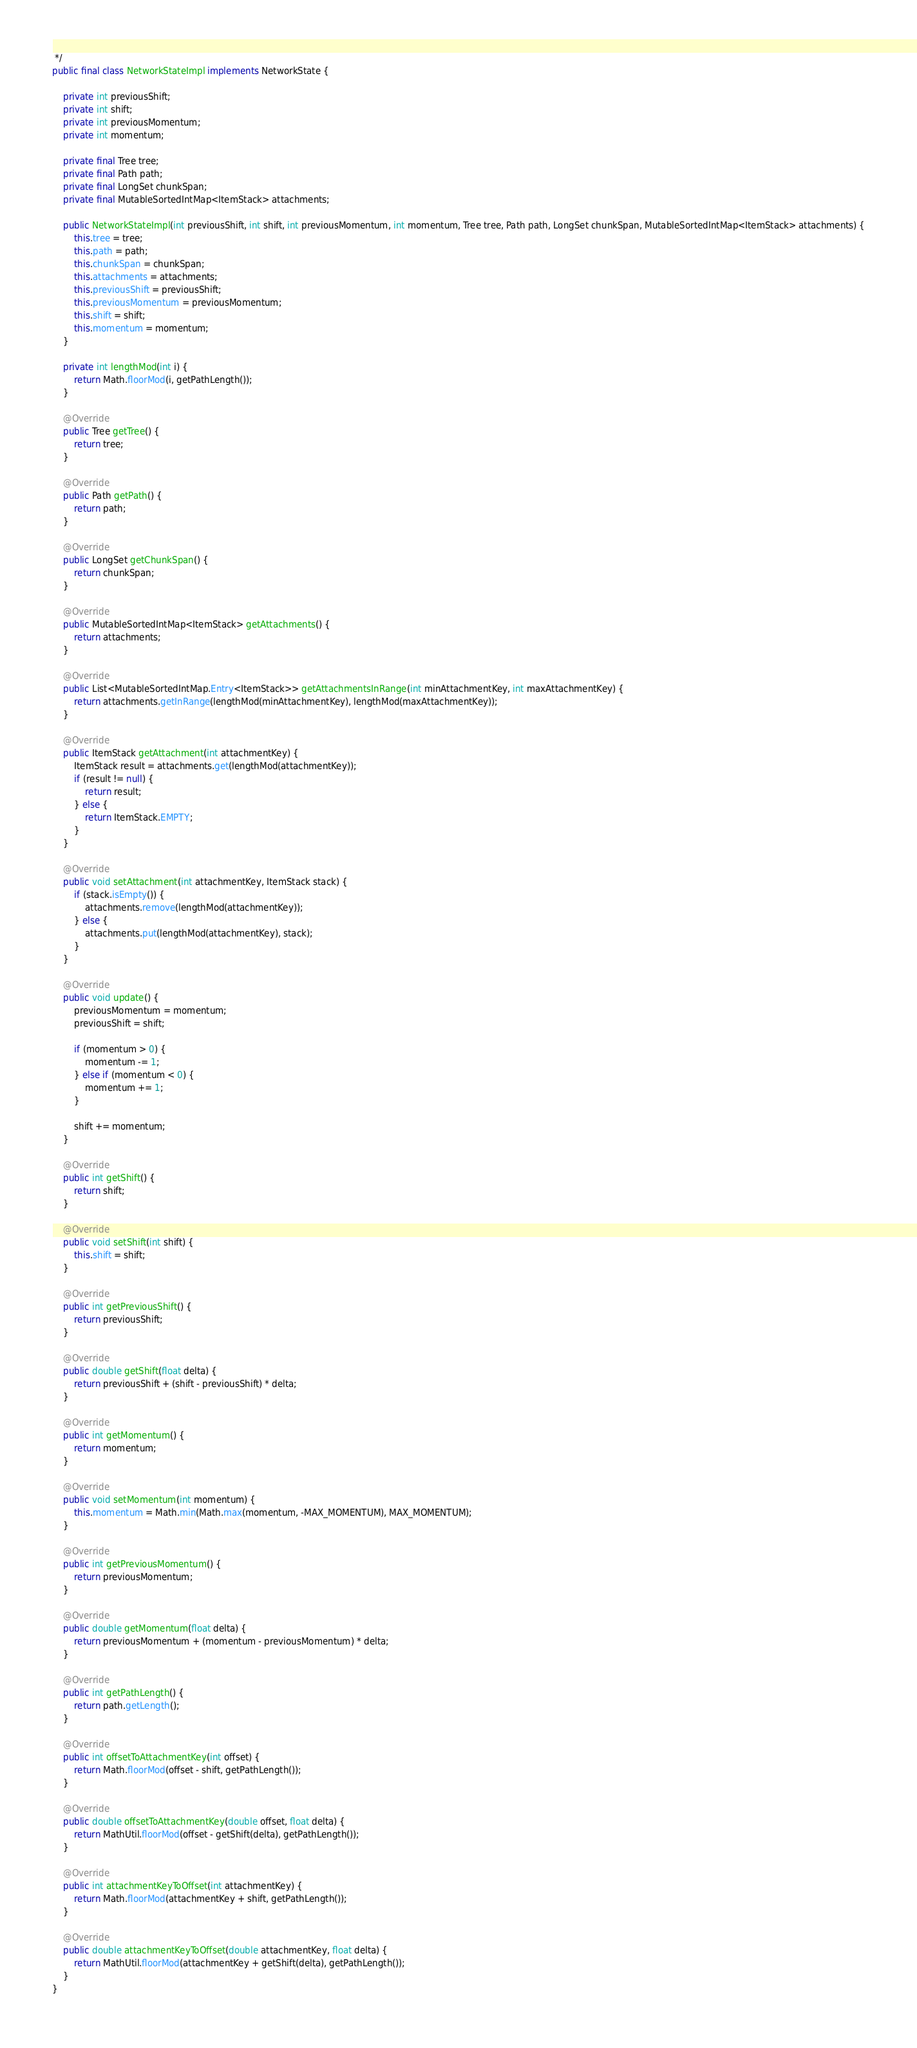<code> <loc_0><loc_0><loc_500><loc_500><_Java_> */
public final class NetworkStateImpl implements NetworkState {

    private int previousShift;
    private int shift;
    private int previousMomentum;
    private int momentum;

    private final Tree tree;
    private final Path path;
    private final LongSet chunkSpan;
    private final MutableSortedIntMap<ItemStack> attachments;

    public NetworkStateImpl(int previousShift, int shift, int previousMomentum, int momentum, Tree tree, Path path, LongSet chunkSpan, MutableSortedIntMap<ItemStack> attachments) {
        this.tree = tree;
        this.path = path;
        this.chunkSpan = chunkSpan;
        this.attachments = attachments;
        this.previousShift = previousShift;
        this.previousMomentum = previousMomentum;
        this.shift = shift;
        this.momentum = momentum;
    }

    private int lengthMod(int i) {
        return Math.floorMod(i, getPathLength());
    }

    @Override
    public Tree getTree() {
        return tree;
    }

    @Override
    public Path getPath() {
        return path;
    }

    @Override
    public LongSet getChunkSpan() {
        return chunkSpan;
    }

    @Override
    public MutableSortedIntMap<ItemStack> getAttachments() {
        return attachments;
    }

    @Override
    public List<MutableSortedIntMap.Entry<ItemStack>> getAttachmentsInRange(int minAttachmentKey, int maxAttachmentKey) {
        return attachments.getInRange(lengthMod(minAttachmentKey), lengthMod(maxAttachmentKey));
    }

    @Override
    public ItemStack getAttachment(int attachmentKey) {
        ItemStack result = attachments.get(lengthMod(attachmentKey));
        if (result != null) {
            return result;
        } else {
            return ItemStack.EMPTY;
        }
    }

    @Override
    public void setAttachment(int attachmentKey, ItemStack stack) {
        if (stack.isEmpty()) {
            attachments.remove(lengthMod(attachmentKey));
        } else {
            attachments.put(lengthMod(attachmentKey), stack);
        }
    }

    @Override
    public void update() {
        previousMomentum = momentum;
        previousShift = shift;

        if (momentum > 0) {
            momentum -= 1;
        } else if (momentum < 0) {
            momentum += 1;
        }

        shift += momentum;
    }

    @Override
    public int getShift() {
        return shift;
    }

    @Override
    public void setShift(int shift) {
        this.shift = shift;
    }

    @Override
    public int getPreviousShift() {
        return previousShift;
    }

    @Override
    public double getShift(float delta) {
        return previousShift + (shift - previousShift) * delta;
    }

    @Override
    public int getMomentum() {
        return momentum;
    }

    @Override
    public void setMomentum(int momentum) {
        this.momentum = Math.min(Math.max(momentum, -MAX_MOMENTUM), MAX_MOMENTUM);
    }

    @Override
    public int getPreviousMomentum() {
        return previousMomentum;
    }

    @Override
    public double getMomentum(float delta) {
        return previousMomentum + (momentum - previousMomentum) * delta;
    }

    @Override
    public int getPathLength() {
        return path.getLength();
    }

    @Override
    public int offsetToAttachmentKey(int offset) {
        return Math.floorMod(offset - shift, getPathLength());
    }

    @Override
    public double offsetToAttachmentKey(double offset, float delta) {
        return MathUtil.floorMod(offset - getShift(delta), getPathLength());
    }

    @Override
    public int attachmentKeyToOffset(int attachmentKey) {
        return Math.floorMod(attachmentKey + shift, getPathLength());
    }

    @Override
    public double attachmentKeyToOffset(double attachmentKey, float delta) {
        return MathUtil.floorMod(attachmentKey + getShift(delta), getPathLength());
    }
}
</code> 